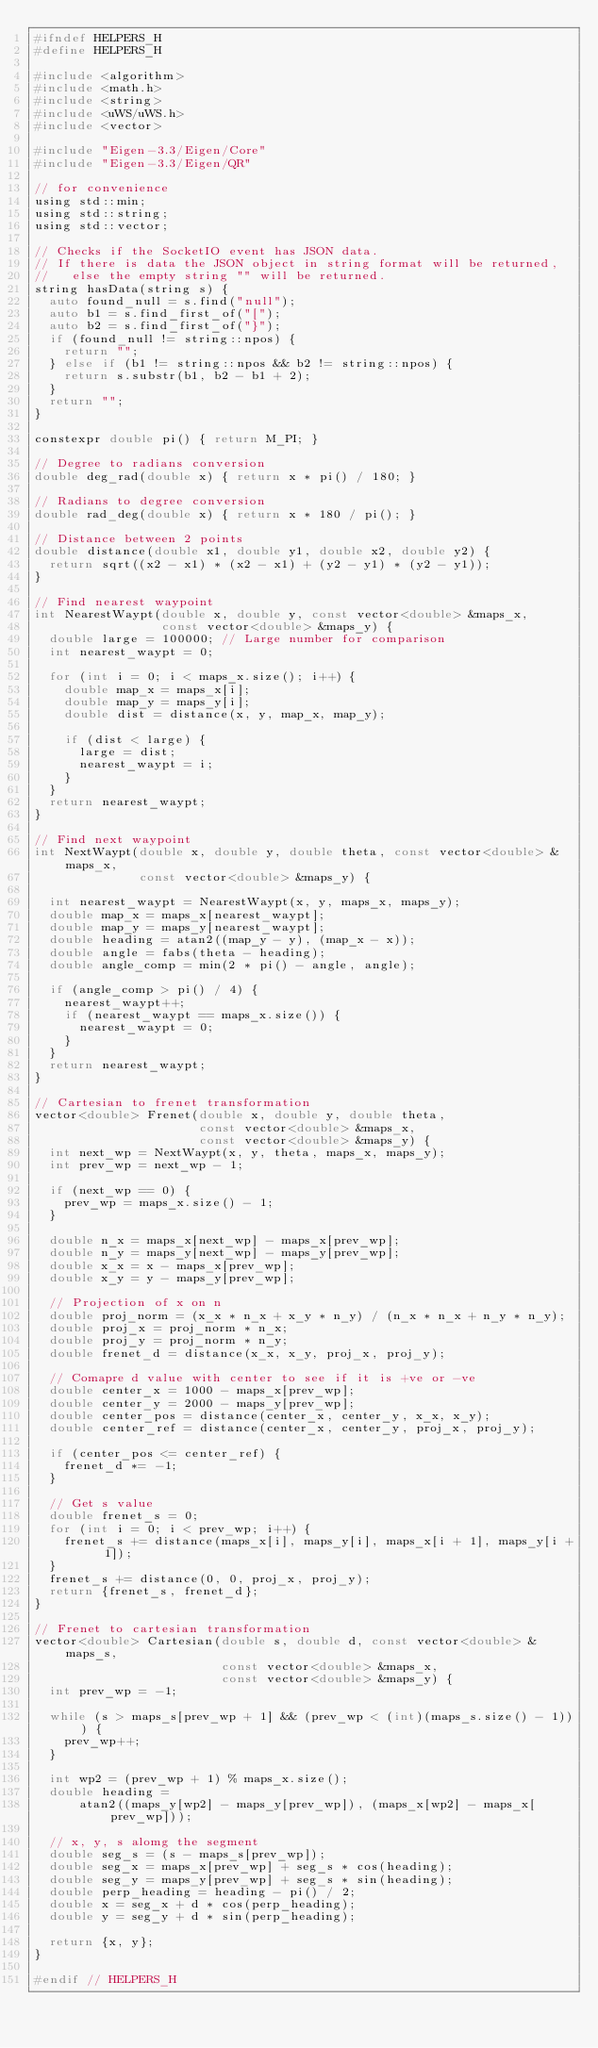Convert code to text. <code><loc_0><loc_0><loc_500><loc_500><_C_>#ifndef HELPERS_H
#define HELPERS_H

#include <algorithm>
#include <math.h>
#include <string>
#include <uWS/uWS.h>
#include <vector>

#include "Eigen-3.3/Eigen/Core"
#include "Eigen-3.3/Eigen/QR"

// for convenience
using std::min;
using std::string;
using std::vector;

// Checks if the SocketIO event has JSON data.
// If there is data the JSON object in string format will be returned,
//   else the empty string "" will be returned.
string hasData(string s) {
  auto found_null = s.find("null");
  auto b1 = s.find_first_of("[");
  auto b2 = s.find_first_of("}");
  if (found_null != string::npos) {
    return "";
  } else if (b1 != string::npos && b2 != string::npos) {
    return s.substr(b1, b2 - b1 + 2);
  }
  return "";
}

constexpr double pi() { return M_PI; }

// Degree to radians conversion
double deg_rad(double x) { return x * pi() / 180; }

// Radians to degree conversion
double rad_deg(double x) { return x * 180 / pi(); }

// Distance between 2 points
double distance(double x1, double y1, double x2, double y2) {
  return sqrt((x2 - x1) * (x2 - x1) + (y2 - y1) * (y2 - y1));
}

// Find nearest waypoint
int NearestWaypt(double x, double y, const vector<double> &maps_x,
                 const vector<double> &maps_y) {
  double large = 100000; // Large number for comparison
  int nearest_waypt = 0;

  for (int i = 0; i < maps_x.size(); i++) {
    double map_x = maps_x[i];
    double map_y = maps_y[i];
    double dist = distance(x, y, map_x, map_y);

    if (dist < large) {
      large = dist;
      nearest_waypt = i;
    }
  }
  return nearest_waypt;
}

// Find next waypoint
int NextWaypt(double x, double y, double theta, const vector<double> &maps_x,
              const vector<double> &maps_y) {

  int nearest_waypt = NearestWaypt(x, y, maps_x, maps_y);
  double map_x = maps_x[nearest_waypt];
  double map_y = maps_y[nearest_waypt];
  double heading = atan2((map_y - y), (map_x - x));
  double angle = fabs(theta - heading);
  double angle_comp = min(2 * pi() - angle, angle);

  if (angle_comp > pi() / 4) {
    nearest_waypt++;
    if (nearest_waypt == maps_x.size()) {
      nearest_waypt = 0;
    }
  }
  return nearest_waypt;
}

// Cartesian to frenet transformation
vector<double> Frenet(double x, double y, double theta,
                      const vector<double> &maps_x,
                      const vector<double> &maps_y) {
  int next_wp = NextWaypt(x, y, theta, maps_x, maps_y);
  int prev_wp = next_wp - 1;

  if (next_wp == 0) {
    prev_wp = maps_x.size() - 1;
  }

  double n_x = maps_x[next_wp] - maps_x[prev_wp];
  double n_y = maps_y[next_wp] - maps_y[prev_wp];
  double x_x = x - maps_x[prev_wp];
  double x_y = y - maps_y[prev_wp];

  // Projection of x on n
  double proj_norm = (x_x * n_x + x_y * n_y) / (n_x * n_x + n_y * n_y);
  double proj_x = proj_norm * n_x;
  double proj_y = proj_norm * n_y;
  double frenet_d = distance(x_x, x_y, proj_x, proj_y);

  // Comapre d value with center to see if it is +ve or -ve
  double center_x = 1000 - maps_x[prev_wp];
  double center_y = 2000 - maps_y[prev_wp];
  double center_pos = distance(center_x, center_y, x_x, x_y);
  double center_ref = distance(center_x, center_y, proj_x, proj_y);

  if (center_pos <= center_ref) {
    frenet_d *= -1;
  }

  // Get s value
  double frenet_s = 0;
  for (int i = 0; i < prev_wp; i++) {
    frenet_s += distance(maps_x[i], maps_y[i], maps_x[i + 1], maps_y[i + 1]);
  }
  frenet_s += distance(0, 0, proj_x, proj_y);
  return {frenet_s, frenet_d};
}

// Frenet to cartesian transformation
vector<double> Cartesian(double s, double d, const vector<double> &maps_s,
                         const vector<double> &maps_x,
                         const vector<double> &maps_y) {
  int prev_wp = -1;

  while (s > maps_s[prev_wp + 1] && (prev_wp < (int)(maps_s.size() - 1))) {
    prev_wp++;
  }

  int wp2 = (prev_wp + 1) % maps_x.size();
  double heading =
      atan2((maps_y[wp2] - maps_y[prev_wp]), (maps_x[wp2] - maps_x[prev_wp]));

  // x, y, s alomg the segment
  double seg_s = (s - maps_s[prev_wp]);
  double seg_x = maps_x[prev_wp] + seg_s * cos(heading);
  double seg_y = maps_y[prev_wp] + seg_s * sin(heading);
  double perp_heading = heading - pi() / 2;
  double x = seg_x + d * cos(perp_heading);
  double y = seg_y + d * sin(perp_heading);

  return {x, y};
}

#endif // HELPERS_H
</code> 